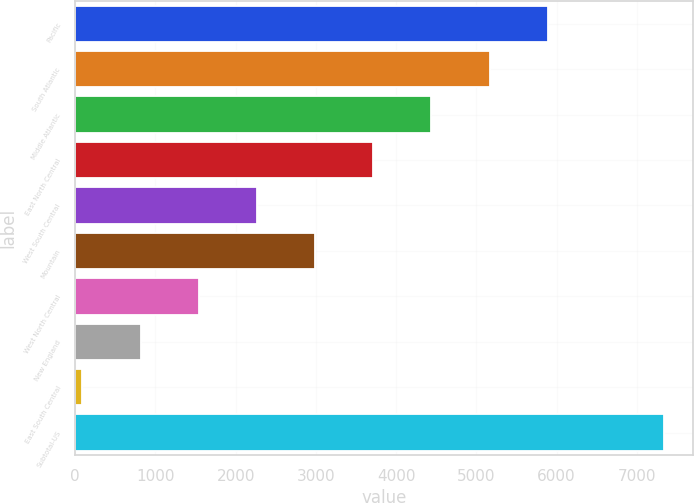Convert chart to OTSL. <chart><loc_0><loc_0><loc_500><loc_500><bar_chart><fcel>Pacific<fcel>South Atlantic<fcel>Middle Atlantic<fcel>East North Central<fcel>West South Central<fcel>Mountain<fcel>West North Central<fcel>New England<fcel>East South Central<fcel>Subtotal-US<nl><fcel>5888.4<fcel>5163.6<fcel>4438.8<fcel>3714<fcel>2264.4<fcel>2989.2<fcel>1539.6<fcel>814.8<fcel>90<fcel>7338<nl></chart> 